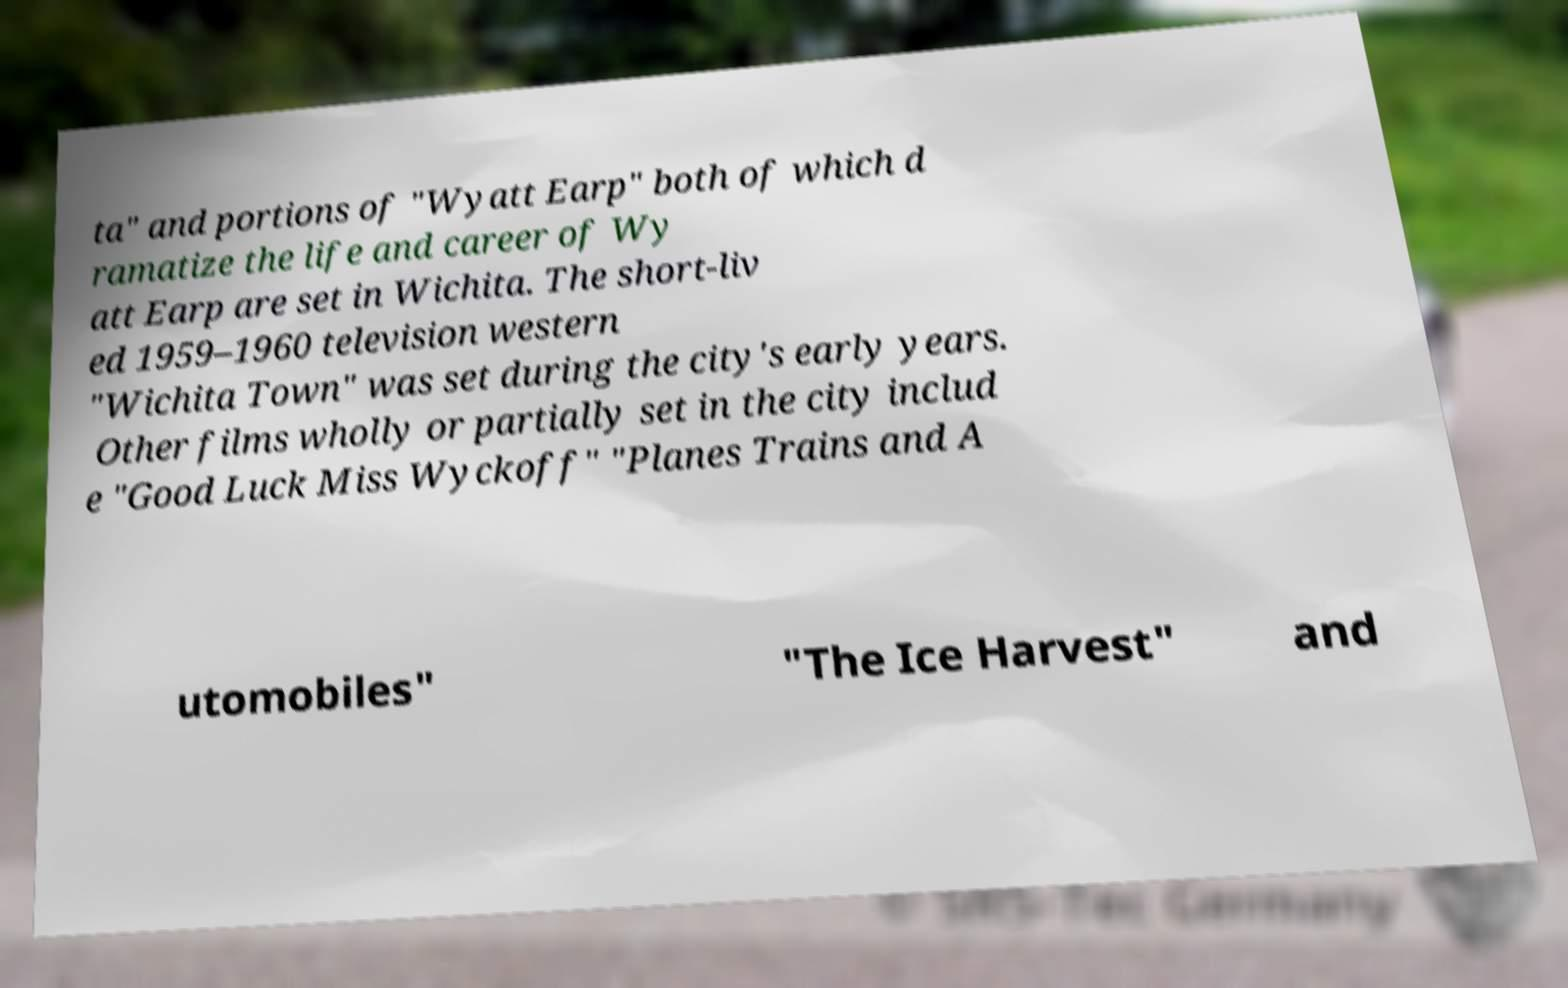Can you read and provide the text displayed in the image?This photo seems to have some interesting text. Can you extract and type it out for me? ta" and portions of "Wyatt Earp" both of which d ramatize the life and career of Wy att Earp are set in Wichita. The short-liv ed 1959–1960 television western "Wichita Town" was set during the city's early years. Other films wholly or partially set in the city includ e "Good Luck Miss Wyckoff" "Planes Trains and A utomobiles" "The Ice Harvest" and 